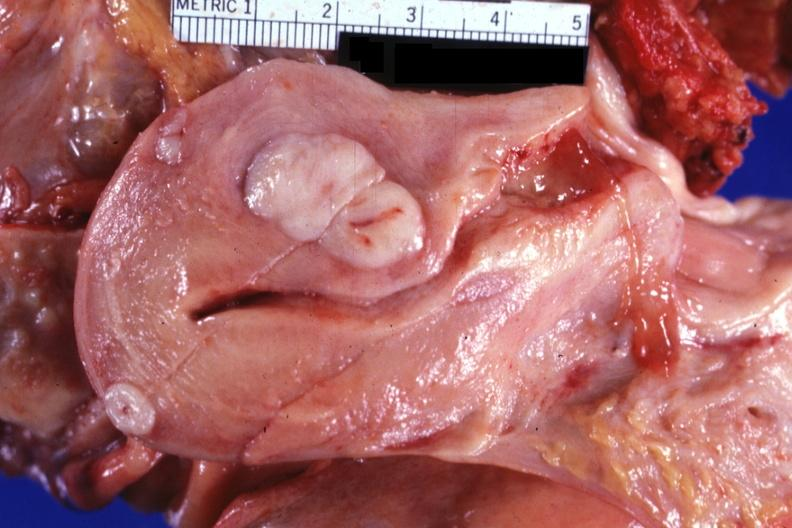s female reproductive present?
Answer the question using a single word or phrase. Yes 